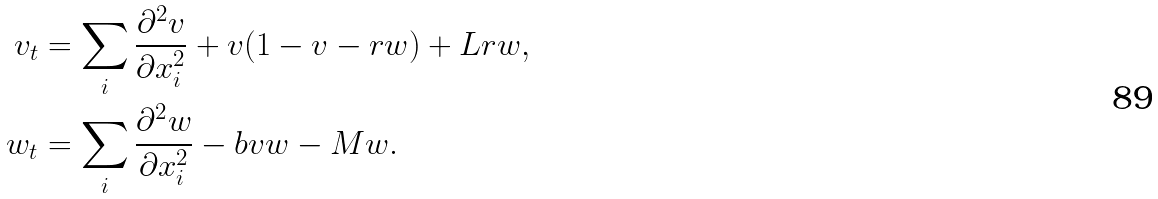<formula> <loc_0><loc_0><loc_500><loc_500>v _ { t } & = \sum _ { i } \frac { \partial ^ { 2 } v } { \partial x _ { i } ^ { 2 } } + v ( 1 - v - r w ) + L r w , \\ w _ { t } & = \sum _ { i } \frac { \partial ^ { 2 } w } { \partial x _ { i } ^ { 2 } } - b v w - M w .</formula> 